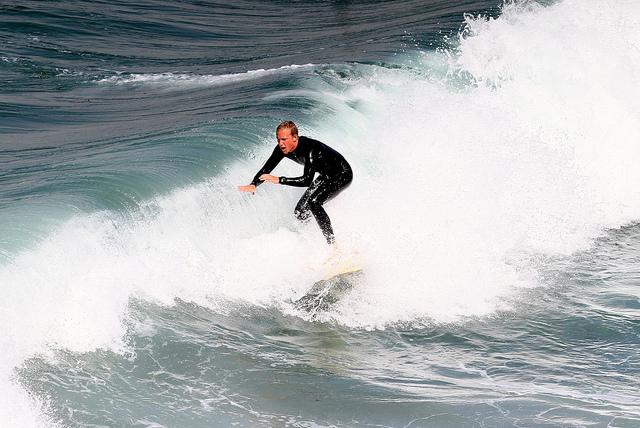What color is the man's wetsuit?
Short answer required. Black. Does the man have one or two legs?
Short answer required. 2. Is the man standing on something?
Concise answer only. Yes. 